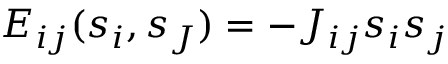Convert formula to latex. <formula><loc_0><loc_0><loc_500><loc_500>E _ { i j } ( s _ { i } , s _ { J } ) = - J _ { i j } s _ { i } s _ { j }</formula> 